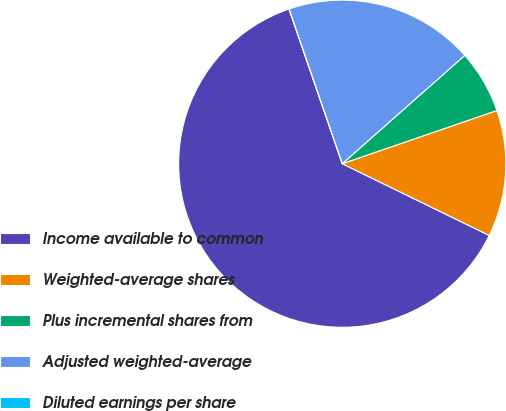Convert chart. <chart><loc_0><loc_0><loc_500><loc_500><pie_chart><fcel>Income available to common<fcel>Weighted-average shares<fcel>Plus incremental shares from<fcel>Adjusted weighted-average<fcel>Diluted earnings per share<nl><fcel>62.5%<fcel>12.5%<fcel>6.25%<fcel>18.75%<fcel>0.0%<nl></chart> 